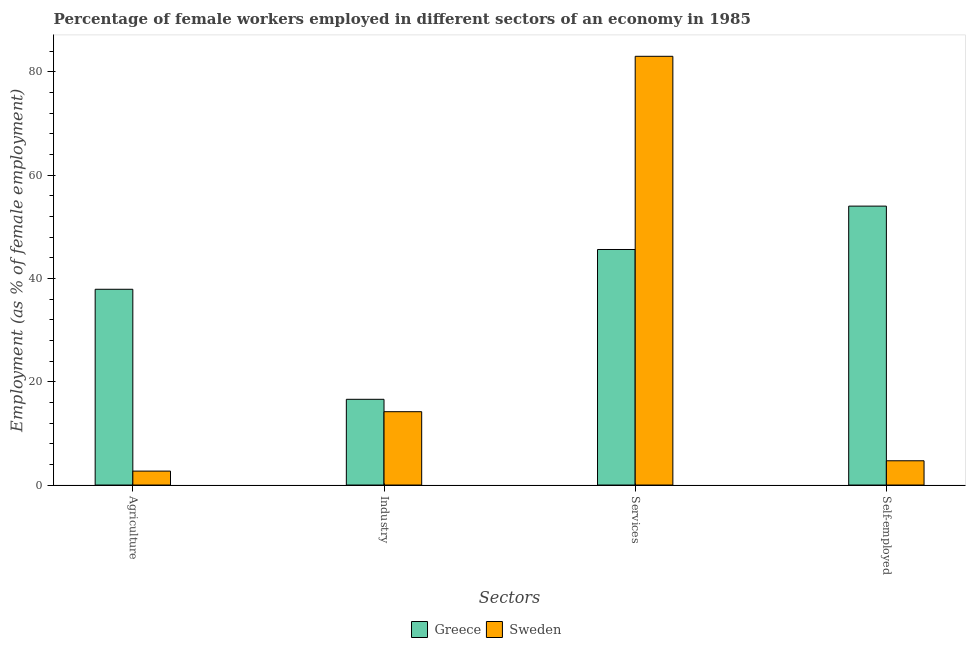What is the label of the 2nd group of bars from the left?
Offer a very short reply. Industry. What is the percentage of female workers in agriculture in Greece?
Provide a succinct answer. 37.9. Across all countries, what is the maximum percentage of female workers in industry?
Keep it short and to the point. 16.6. Across all countries, what is the minimum percentage of female workers in services?
Provide a succinct answer. 45.6. What is the total percentage of self employed female workers in the graph?
Offer a terse response. 58.7. What is the difference between the percentage of female workers in services in Greece and that in Sweden?
Your answer should be compact. -37.4. What is the difference between the percentage of female workers in agriculture in Greece and the percentage of female workers in services in Sweden?
Offer a very short reply. -45.1. What is the average percentage of female workers in services per country?
Give a very brief answer. 64.3. What is the difference between the percentage of female workers in services and percentage of female workers in industry in Greece?
Make the answer very short. 29. In how many countries, is the percentage of female workers in services greater than 36 %?
Ensure brevity in your answer.  2. What is the ratio of the percentage of female workers in agriculture in Sweden to that in Greece?
Keep it short and to the point. 0.07. What is the difference between the highest and the second highest percentage of female workers in services?
Keep it short and to the point. 37.4. What is the difference between the highest and the lowest percentage of female workers in industry?
Provide a succinct answer. 2.4. Is the sum of the percentage of self employed female workers in Sweden and Greece greater than the maximum percentage of female workers in services across all countries?
Provide a short and direct response. No. Is it the case that in every country, the sum of the percentage of self employed female workers and percentage of female workers in industry is greater than the sum of percentage of female workers in agriculture and percentage of female workers in services?
Your answer should be very brief. No. What does the 2nd bar from the left in Self-employed represents?
Your answer should be compact. Sweden. What does the 2nd bar from the right in Agriculture represents?
Provide a succinct answer. Greece. Are the values on the major ticks of Y-axis written in scientific E-notation?
Your answer should be very brief. No. Does the graph contain any zero values?
Ensure brevity in your answer.  No. Does the graph contain grids?
Your answer should be very brief. No. How are the legend labels stacked?
Your answer should be very brief. Horizontal. What is the title of the graph?
Provide a short and direct response. Percentage of female workers employed in different sectors of an economy in 1985. What is the label or title of the X-axis?
Offer a terse response. Sectors. What is the label or title of the Y-axis?
Offer a terse response. Employment (as % of female employment). What is the Employment (as % of female employment) in Greece in Agriculture?
Make the answer very short. 37.9. What is the Employment (as % of female employment) in Sweden in Agriculture?
Offer a terse response. 2.7. What is the Employment (as % of female employment) of Greece in Industry?
Provide a short and direct response. 16.6. What is the Employment (as % of female employment) in Sweden in Industry?
Your response must be concise. 14.2. What is the Employment (as % of female employment) of Greece in Services?
Provide a short and direct response. 45.6. What is the Employment (as % of female employment) in Sweden in Services?
Provide a short and direct response. 83. What is the Employment (as % of female employment) in Greece in Self-employed?
Give a very brief answer. 54. What is the Employment (as % of female employment) of Sweden in Self-employed?
Provide a succinct answer. 4.7. Across all Sectors, what is the minimum Employment (as % of female employment) in Greece?
Provide a short and direct response. 16.6. Across all Sectors, what is the minimum Employment (as % of female employment) of Sweden?
Offer a terse response. 2.7. What is the total Employment (as % of female employment) in Greece in the graph?
Offer a very short reply. 154.1. What is the total Employment (as % of female employment) in Sweden in the graph?
Give a very brief answer. 104.6. What is the difference between the Employment (as % of female employment) in Greece in Agriculture and that in Industry?
Make the answer very short. 21.3. What is the difference between the Employment (as % of female employment) in Sweden in Agriculture and that in Industry?
Provide a succinct answer. -11.5. What is the difference between the Employment (as % of female employment) in Sweden in Agriculture and that in Services?
Your answer should be compact. -80.3. What is the difference between the Employment (as % of female employment) of Greece in Agriculture and that in Self-employed?
Offer a terse response. -16.1. What is the difference between the Employment (as % of female employment) in Sweden in Agriculture and that in Self-employed?
Your answer should be very brief. -2. What is the difference between the Employment (as % of female employment) of Sweden in Industry and that in Services?
Provide a succinct answer. -68.8. What is the difference between the Employment (as % of female employment) of Greece in Industry and that in Self-employed?
Keep it short and to the point. -37.4. What is the difference between the Employment (as % of female employment) in Sweden in Industry and that in Self-employed?
Your response must be concise. 9.5. What is the difference between the Employment (as % of female employment) of Sweden in Services and that in Self-employed?
Offer a terse response. 78.3. What is the difference between the Employment (as % of female employment) in Greece in Agriculture and the Employment (as % of female employment) in Sweden in Industry?
Ensure brevity in your answer.  23.7. What is the difference between the Employment (as % of female employment) in Greece in Agriculture and the Employment (as % of female employment) in Sweden in Services?
Your answer should be compact. -45.1. What is the difference between the Employment (as % of female employment) of Greece in Agriculture and the Employment (as % of female employment) of Sweden in Self-employed?
Ensure brevity in your answer.  33.2. What is the difference between the Employment (as % of female employment) in Greece in Industry and the Employment (as % of female employment) in Sweden in Services?
Provide a succinct answer. -66.4. What is the difference between the Employment (as % of female employment) of Greece in Services and the Employment (as % of female employment) of Sweden in Self-employed?
Offer a terse response. 40.9. What is the average Employment (as % of female employment) of Greece per Sectors?
Offer a very short reply. 38.52. What is the average Employment (as % of female employment) of Sweden per Sectors?
Keep it short and to the point. 26.15. What is the difference between the Employment (as % of female employment) of Greece and Employment (as % of female employment) of Sweden in Agriculture?
Provide a short and direct response. 35.2. What is the difference between the Employment (as % of female employment) in Greece and Employment (as % of female employment) in Sweden in Services?
Your response must be concise. -37.4. What is the difference between the Employment (as % of female employment) in Greece and Employment (as % of female employment) in Sweden in Self-employed?
Ensure brevity in your answer.  49.3. What is the ratio of the Employment (as % of female employment) in Greece in Agriculture to that in Industry?
Make the answer very short. 2.28. What is the ratio of the Employment (as % of female employment) of Sweden in Agriculture to that in Industry?
Your answer should be very brief. 0.19. What is the ratio of the Employment (as % of female employment) of Greece in Agriculture to that in Services?
Offer a terse response. 0.83. What is the ratio of the Employment (as % of female employment) of Sweden in Agriculture to that in Services?
Your answer should be compact. 0.03. What is the ratio of the Employment (as % of female employment) of Greece in Agriculture to that in Self-employed?
Make the answer very short. 0.7. What is the ratio of the Employment (as % of female employment) of Sweden in Agriculture to that in Self-employed?
Give a very brief answer. 0.57. What is the ratio of the Employment (as % of female employment) in Greece in Industry to that in Services?
Your answer should be very brief. 0.36. What is the ratio of the Employment (as % of female employment) in Sweden in Industry to that in Services?
Your response must be concise. 0.17. What is the ratio of the Employment (as % of female employment) of Greece in Industry to that in Self-employed?
Ensure brevity in your answer.  0.31. What is the ratio of the Employment (as % of female employment) of Sweden in Industry to that in Self-employed?
Give a very brief answer. 3.02. What is the ratio of the Employment (as % of female employment) of Greece in Services to that in Self-employed?
Offer a terse response. 0.84. What is the ratio of the Employment (as % of female employment) in Sweden in Services to that in Self-employed?
Make the answer very short. 17.66. What is the difference between the highest and the second highest Employment (as % of female employment) in Greece?
Give a very brief answer. 8.4. What is the difference between the highest and the second highest Employment (as % of female employment) of Sweden?
Offer a very short reply. 68.8. What is the difference between the highest and the lowest Employment (as % of female employment) in Greece?
Provide a succinct answer. 37.4. What is the difference between the highest and the lowest Employment (as % of female employment) of Sweden?
Make the answer very short. 80.3. 